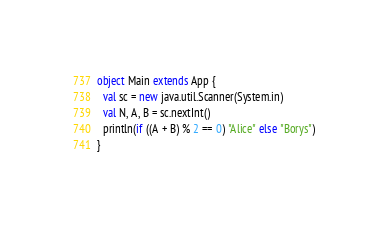Convert code to text. <code><loc_0><loc_0><loc_500><loc_500><_Scala_>object Main extends App {
  val sc = new java.util.Scanner(System.in)
  val N, A, B = sc.nextInt()
  println(if ((A + B) % 2 == 0) "Alice" else "Borys")
}
</code> 